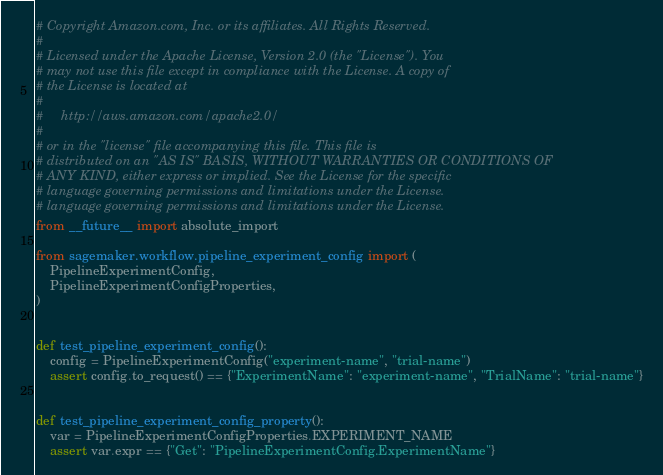<code> <loc_0><loc_0><loc_500><loc_500><_Python_># Copyright Amazon.com, Inc. or its affiliates. All Rights Reserved.
#
# Licensed under the Apache License, Version 2.0 (the "License"). You
# may not use this file except in compliance with the License. A copy of
# the License is located at
#
#     http://aws.amazon.com/apache2.0/
#
# or in the "license" file accompanying this file. This file is
# distributed on an "AS IS" BASIS, WITHOUT WARRANTIES OR CONDITIONS OF
# ANY KIND, either express or implied. See the License for the specific
# language governing permissions and limitations under the License.
# language governing permissions and limitations under the License.
from __future__ import absolute_import

from sagemaker.workflow.pipeline_experiment_config import (
    PipelineExperimentConfig,
    PipelineExperimentConfigProperties,
)


def test_pipeline_experiment_config():
    config = PipelineExperimentConfig("experiment-name", "trial-name")
    assert config.to_request() == {"ExperimentName": "experiment-name", "TrialName": "trial-name"}


def test_pipeline_experiment_config_property():
    var = PipelineExperimentConfigProperties.EXPERIMENT_NAME
    assert var.expr == {"Get": "PipelineExperimentConfig.ExperimentName"}
</code> 